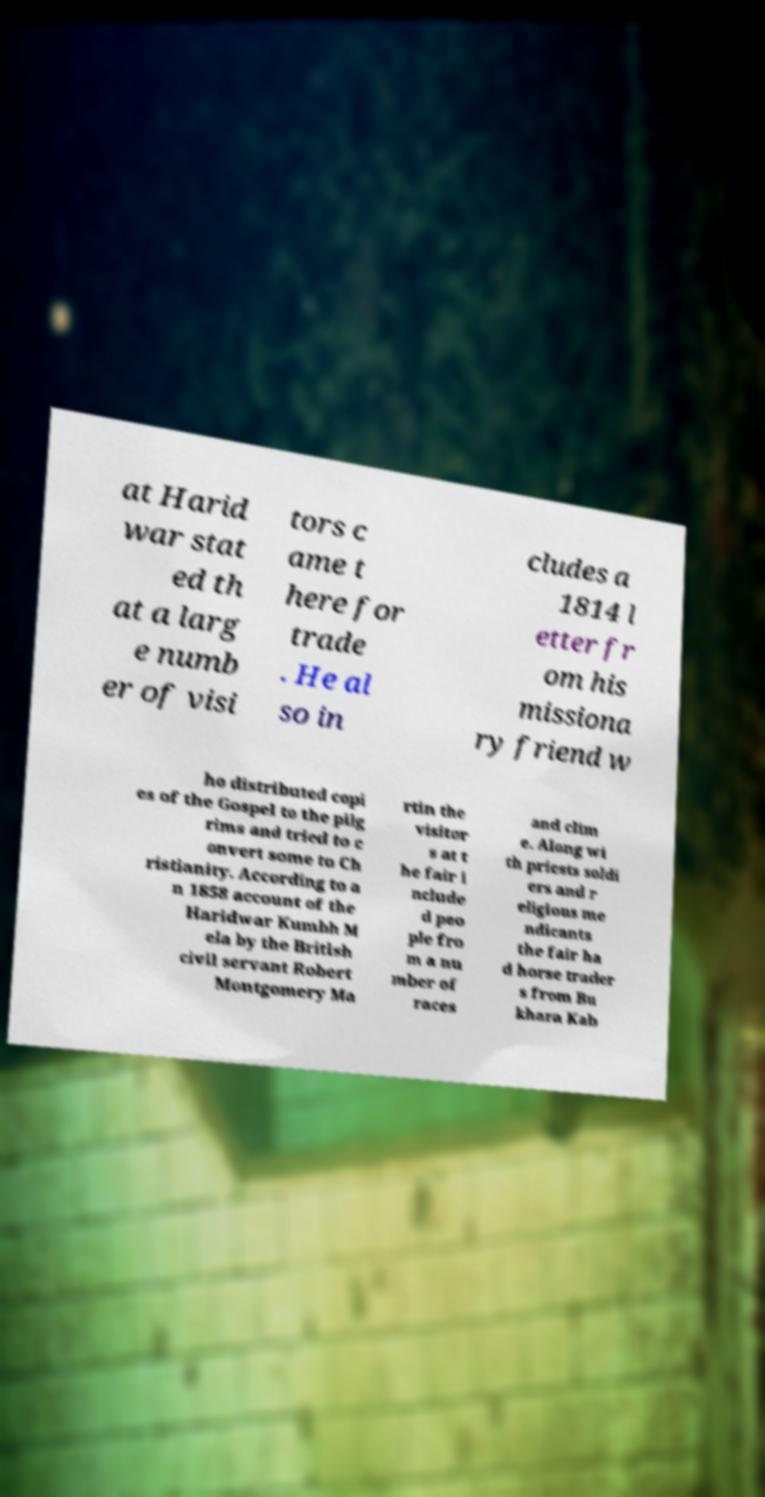Please identify and transcribe the text found in this image. at Harid war stat ed th at a larg e numb er of visi tors c ame t here for trade . He al so in cludes a 1814 l etter fr om his missiona ry friend w ho distributed copi es of the Gospel to the pilg rims and tried to c onvert some to Ch ristianity. According to a n 1858 account of the Haridwar Kumbh M ela by the British civil servant Robert Montgomery Ma rtin the visitor s at t he fair i nclude d peo ple fro m a nu mber of races and clim e. Along wi th priests soldi ers and r eligious me ndicants the fair ha d horse trader s from Bu khara Kab 